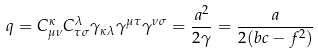Convert formula to latex. <formula><loc_0><loc_0><loc_500><loc_500>q = C ^ { \kappa } _ { \mu \nu } C ^ { \lambda } _ { \tau \sigma } \gamma _ { \kappa \lambda } \gamma ^ { \mu \tau } \gamma ^ { \nu \sigma } = \frac { a ^ { 2 } } { 2 \gamma } = \frac { a } { 2 ( b c - f ^ { 2 } ) }</formula> 